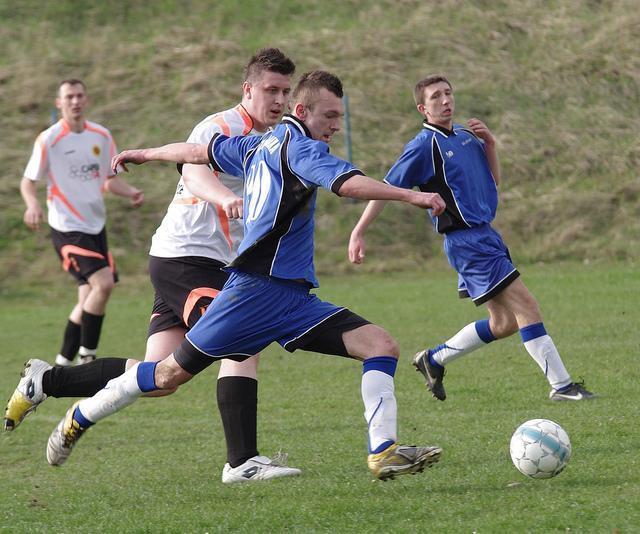How many people are in the photo?
Give a very brief answer. 4. 